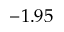<formula> <loc_0><loc_0><loc_500><loc_500>- 1 . 9 5</formula> 